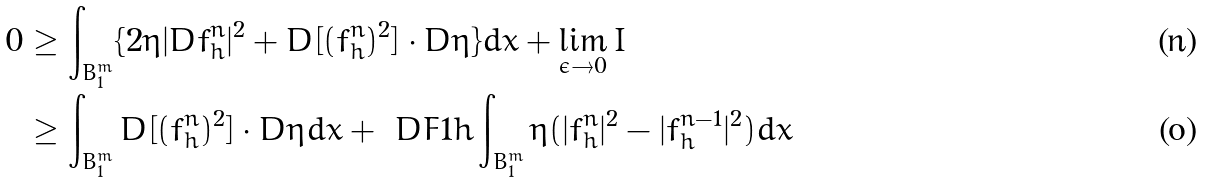<formula> <loc_0><loc_0><loc_500><loc_500>0 & \geq \int _ { B _ { 1 } ^ { m } } \{ 2 \eta | D f _ { h } ^ { n } | ^ { 2 } + D [ ( f _ { h } ^ { n } ) ^ { 2 } ] \cdot D \eta \} d x + \lim _ { \epsilon \to 0 } I \\ & \geq \int _ { B _ { 1 } ^ { m } } D [ ( f _ { h } ^ { n } ) ^ { 2 } ] \cdot D \eta d x + \ D F { 1 } { h } \int _ { B _ { 1 } ^ { m } } \eta ( | f _ { h } ^ { n } | ^ { 2 } - | f _ { h } ^ { n - 1 } | ^ { 2 } ) d x</formula> 